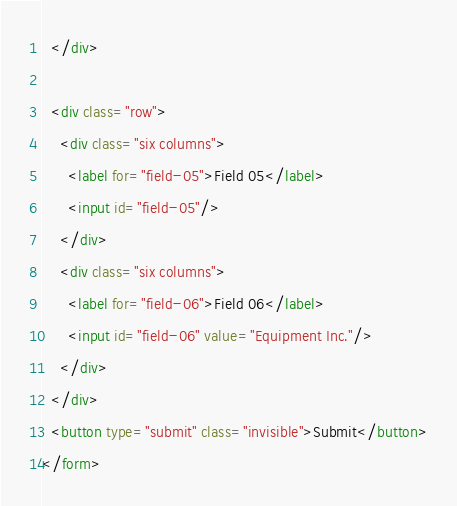Convert code to text. <code><loc_0><loc_0><loc_500><loc_500><_HTML_>  </div>

  <div class="row">
    <div class="six columns">
      <label for="field-05">Field 05</label>
      <input id="field-05"/>
    </div>
    <div class="six columns">
      <label for="field-06">Field 06</label>
      <input id="field-06" value="Equipment Inc."/>
    </div>
  </div>
  <button type="submit" class="invisible">Submit</button>
</form>
</code> 